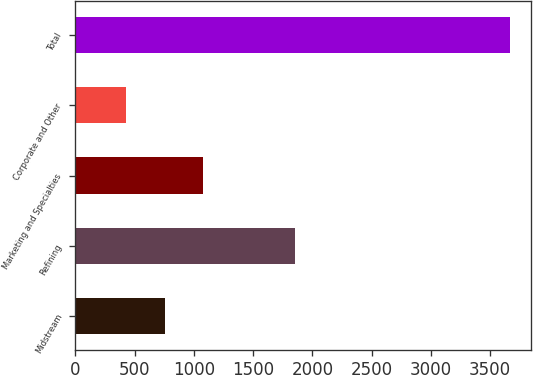<chart> <loc_0><loc_0><loc_500><loc_500><bar_chart><fcel>Midstream<fcel>Refining<fcel>Marketing and Specialties<fcel>Corporate and Other<fcel>Total<nl><fcel>754.4<fcel>1851<fcel>1077.8<fcel>431<fcel>3665<nl></chart> 